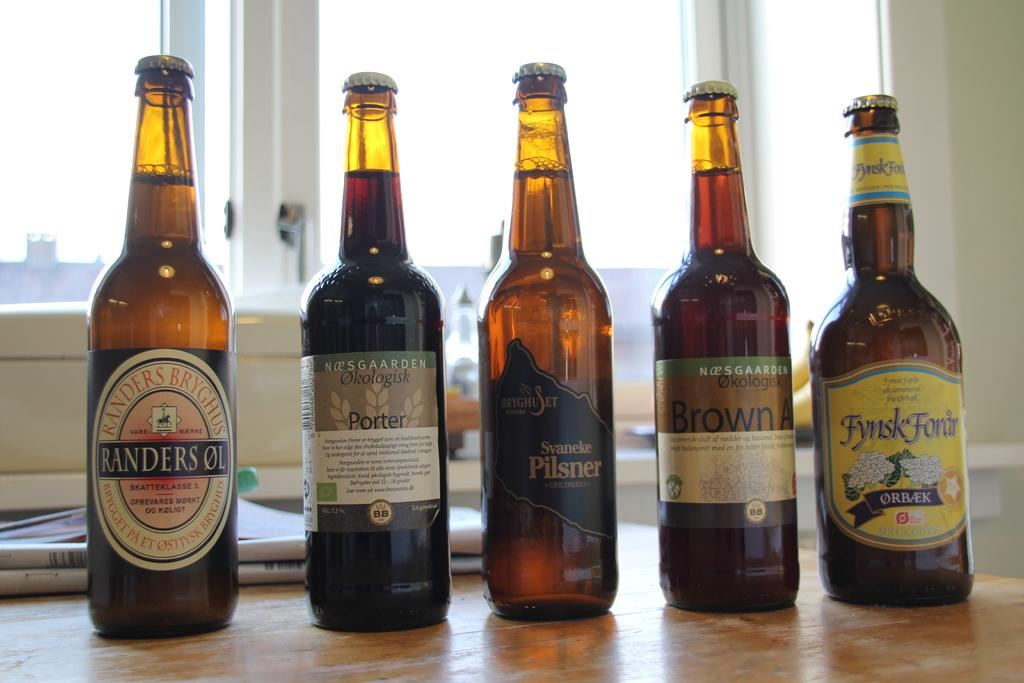<image>
Present a compact description of the photo's key features. Five different bottles of beer are shown side-by-side on a table. 